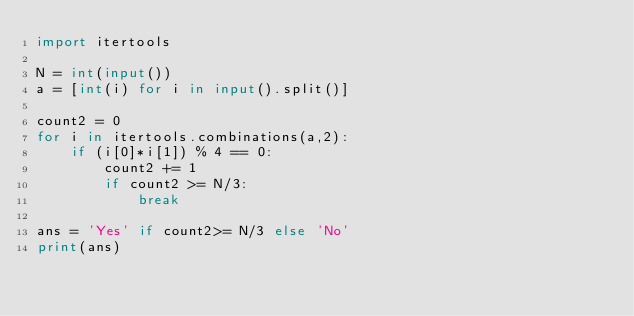<code> <loc_0><loc_0><loc_500><loc_500><_Python_>import itertools

N = int(input())
a = [int(i) for i in input().split()]

count2 = 0
for i in itertools.combinations(a,2):
    if (i[0]*i[1]) % 4 == 0:
        count2 += 1
        if count2 >= N/3:
            break

ans = 'Yes' if count2>= N/3 else 'No'
print(ans)</code> 